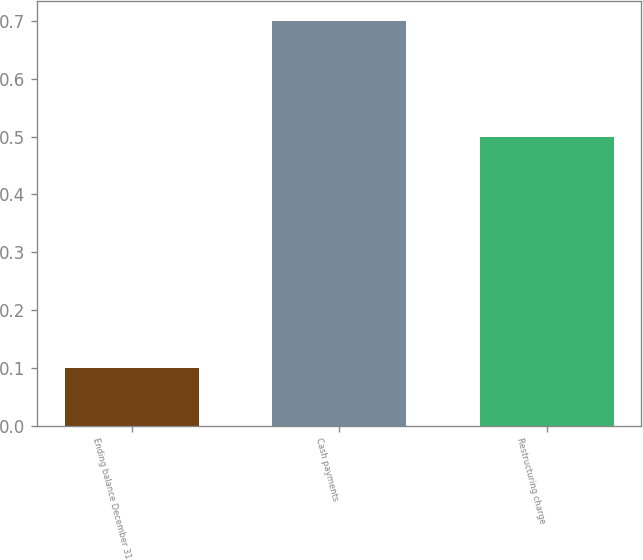<chart> <loc_0><loc_0><loc_500><loc_500><bar_chart><fcel>Ending balance December 31<fcel>Cash payments<fcel>Restructuring charge<nl><fcel>0.1<fcel>0.7<fcel>0.5<nl></chart> 